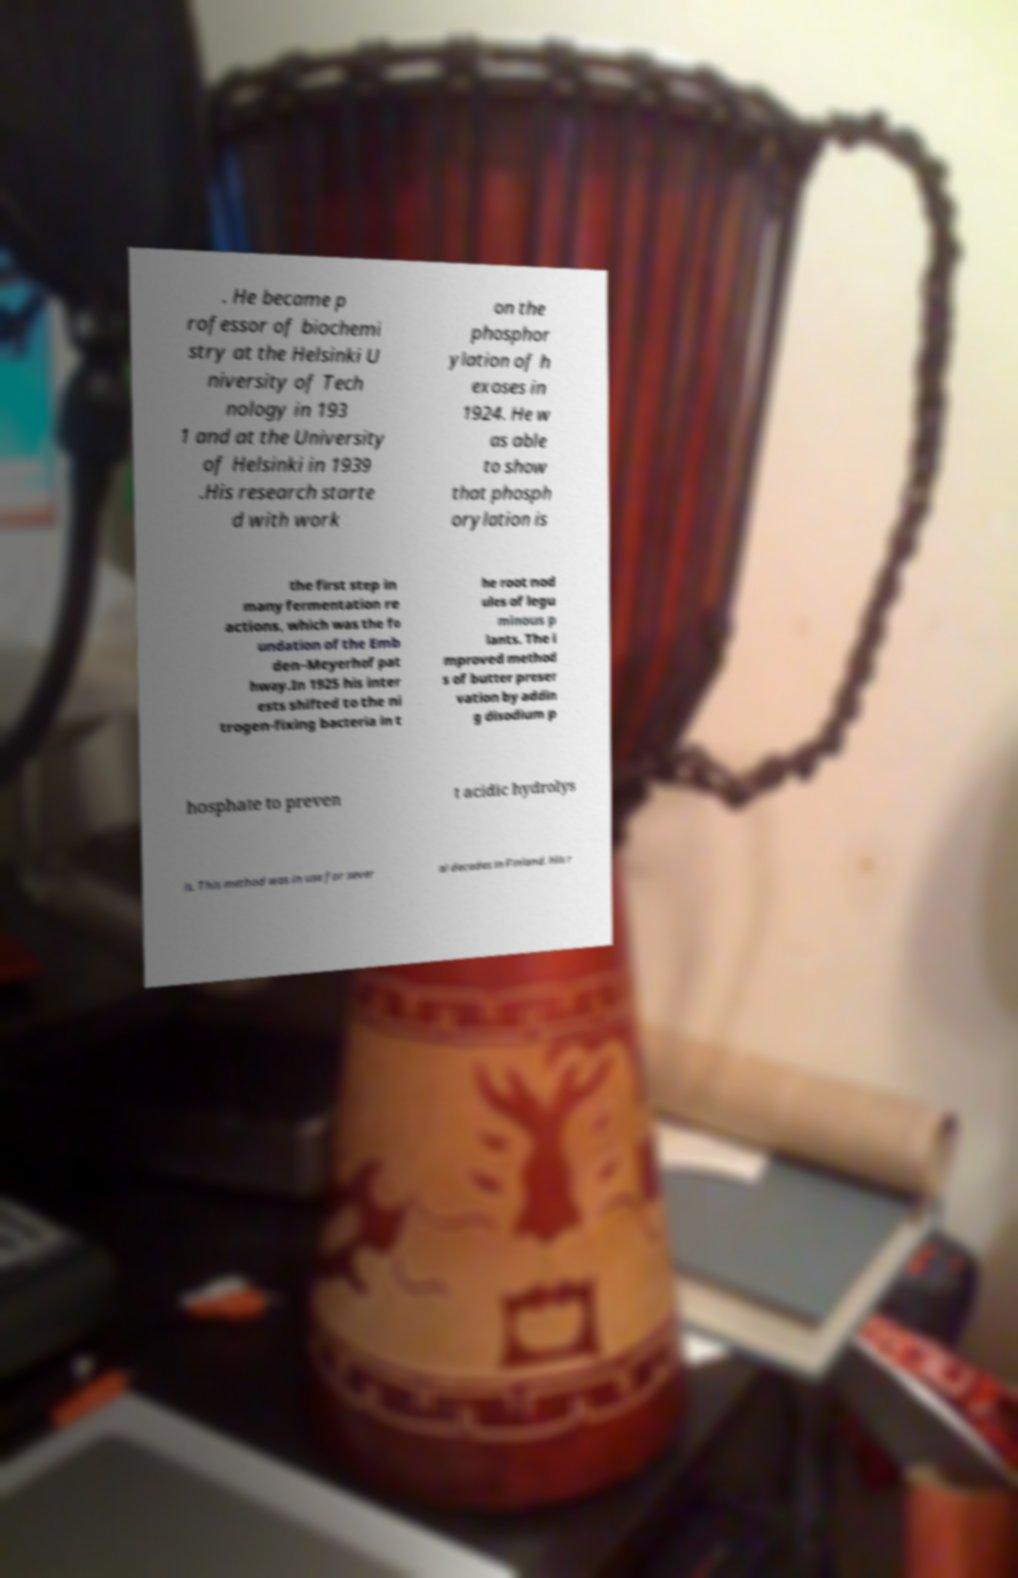What messages or text are displayed in this image? I need them in a readable, typed format. . He became p rofessor of biochemi stry at the Helsinki U niversity of Tech nology in 193 1 and at the University of Helsinki in 1939 .His research starte d with work on the phosphor ylation of h exoses in 1924. He w as able to show that phosph orylation is the first step in many fermentation re actions, which was the fo undation of the Emb den–Meyerhof pat hway.In 1925 his inter ests shifted to the ni trogen-fixing bacteria in t he root nod ules of legu minous p lants. The i mproved method s of butter preser vation by addin g disodium p hosphate to preven t acidic hydrolys is. This method was in use for sever al decades in Finland. His r 